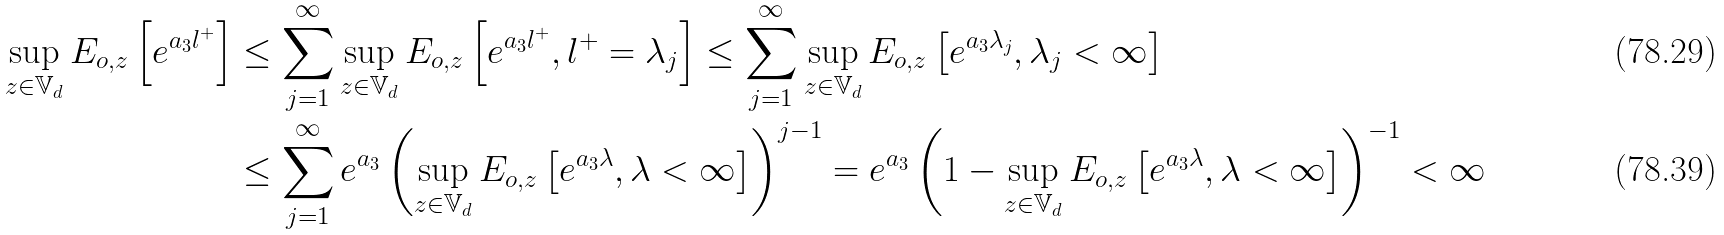Convert formula to latex. <formula><loc_0><loc_0><loc_500><loc_500>\sup _ { z \in \mathbb { V } _ { d } } E _ { o , z } \left [ e ^ { a _ { 3 } l ^ { + } } \right ] & \leq \sum _ { j = 1 } ^ { \infty } \sup _ { z \in \mathbb { V } _ { d } } E _ { o , z } \left [ e ^ { a _ { 3 } l ^ { + } } , l ^ { + } = \lambda _ { j } \right ] \leq \sum _ { j = 1 } ^ { \infty } \sup _ { z \in \mathbb { V } _ { d } } E _ { o , z } \left [ e ^ { a _ { 3 } \lambda _ { j } } , \lambda _ { j } < \infty \right ] \\ & \leq \sum _ { j = 1 } ^ { \infty } e ^ { a _ { 3 } } \left ( \sup _ { z \in \mathbb { V } _ { d } } E _ { o , z } \left [ e ^ { a _ { 3 } \lambda } , \lambda < \infty \right ] \right ) ^ { j - 1 } = e ^ { a _ { 3 } } \left ( 1 - \sup _ { z \in \mathbb { V } _ { d } } E _ { o , z } \left [ e ^ { a _ { 3 } \lambda } , \lambda < \infty \right ] \right ) ^ { - 1 } < \infty</formula> 